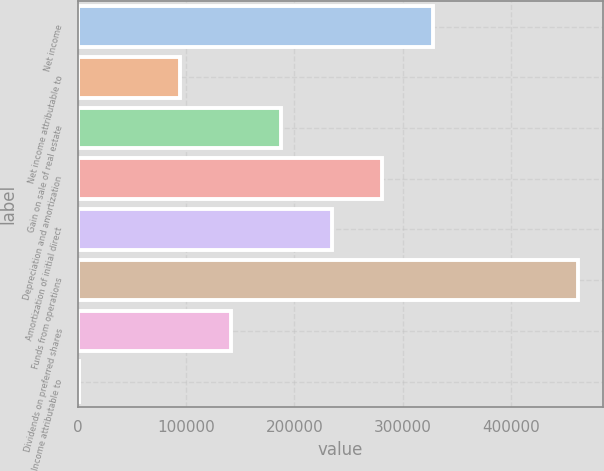Convert chart to OTSL. <chart><loc_0><loc_0><loc_500><loc_500><bar_chart><fcel>Net income<fcel>Net income attributable to<fcel>Gain on sale of real estate<fcel>Depreciation and amortization<fcel>Amortization of initial direct<fcel>Funds from operations<fcel>Dividends on preferred shares<fcel>Income attributable to<nl><fcel>327826<fcel>94713.8<fcel>187959<fcel>281203<fcel>234581<fcel>461777<fcel>141336<fcel>1469<nl></chart> 